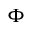<formula> <loc_0><loc_0><loc_500><loc_500>\Phi</formula> 